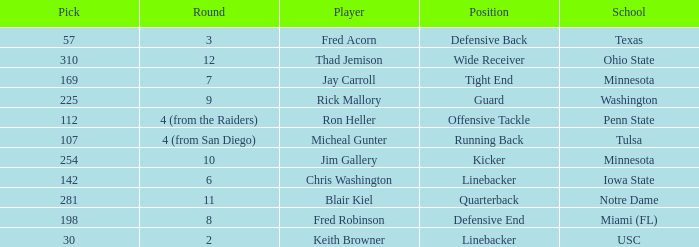Could you parse the entire table? {'header': ['Pick', 'Round', 'Player', 'Position', 'School'], 'rows': [['57', '3', 'Fred Acorn', 'Defensive Back', 'Texas'], ['310', '12', 'Thad Jemison', 'Wide Receiver', 'Ohio State'], ['169', '7', 'Jay Carroll', 'Tight End', 'Minnesota'], ['225', '9', 'Rick Mallory', 'Guard', 'Washington'], ['112', '4 (from the Raiders)', 'Ron Heller', 'Offensive Tackle', 'Penn State'], ['107', '4 (from San Diego)', 'Micheal Gunter', 'Running Back', 'Tulsa'], ['254', '10', 'Jim Gallery', 'Kicker', 'Minnesota'], ['142', '6', 'Chris Washington', 'Linebacker', 'Iowa State'], ['281', '11', 'Blair Kiel', 'Quarterback', 'Notre Dame'], ['198', '8', 'Fred Robinson', 'Defensive End', 'Miami (FL)'], ['30', '2', 'Keith Browner', 'Linebacker', 'USC']]} What is the total pick number for a wide receiver? 1.0. 